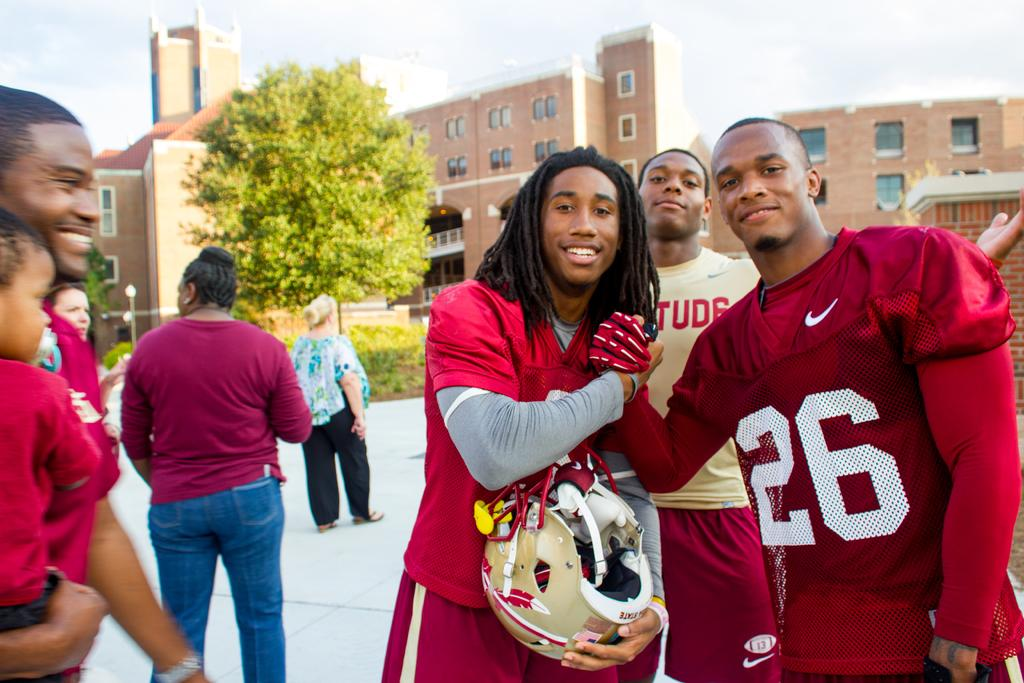Provide a one-sentence caption for the provided image. Two African American college males wear red football uniforms as they grasp hands and smile with a backdrop of college dorms and random people milling about.. 